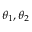<formula> <loc_0><loc_0><loc_500><loc_500>\theta _ { 1 } , \theta _ { 2 }</formula> 